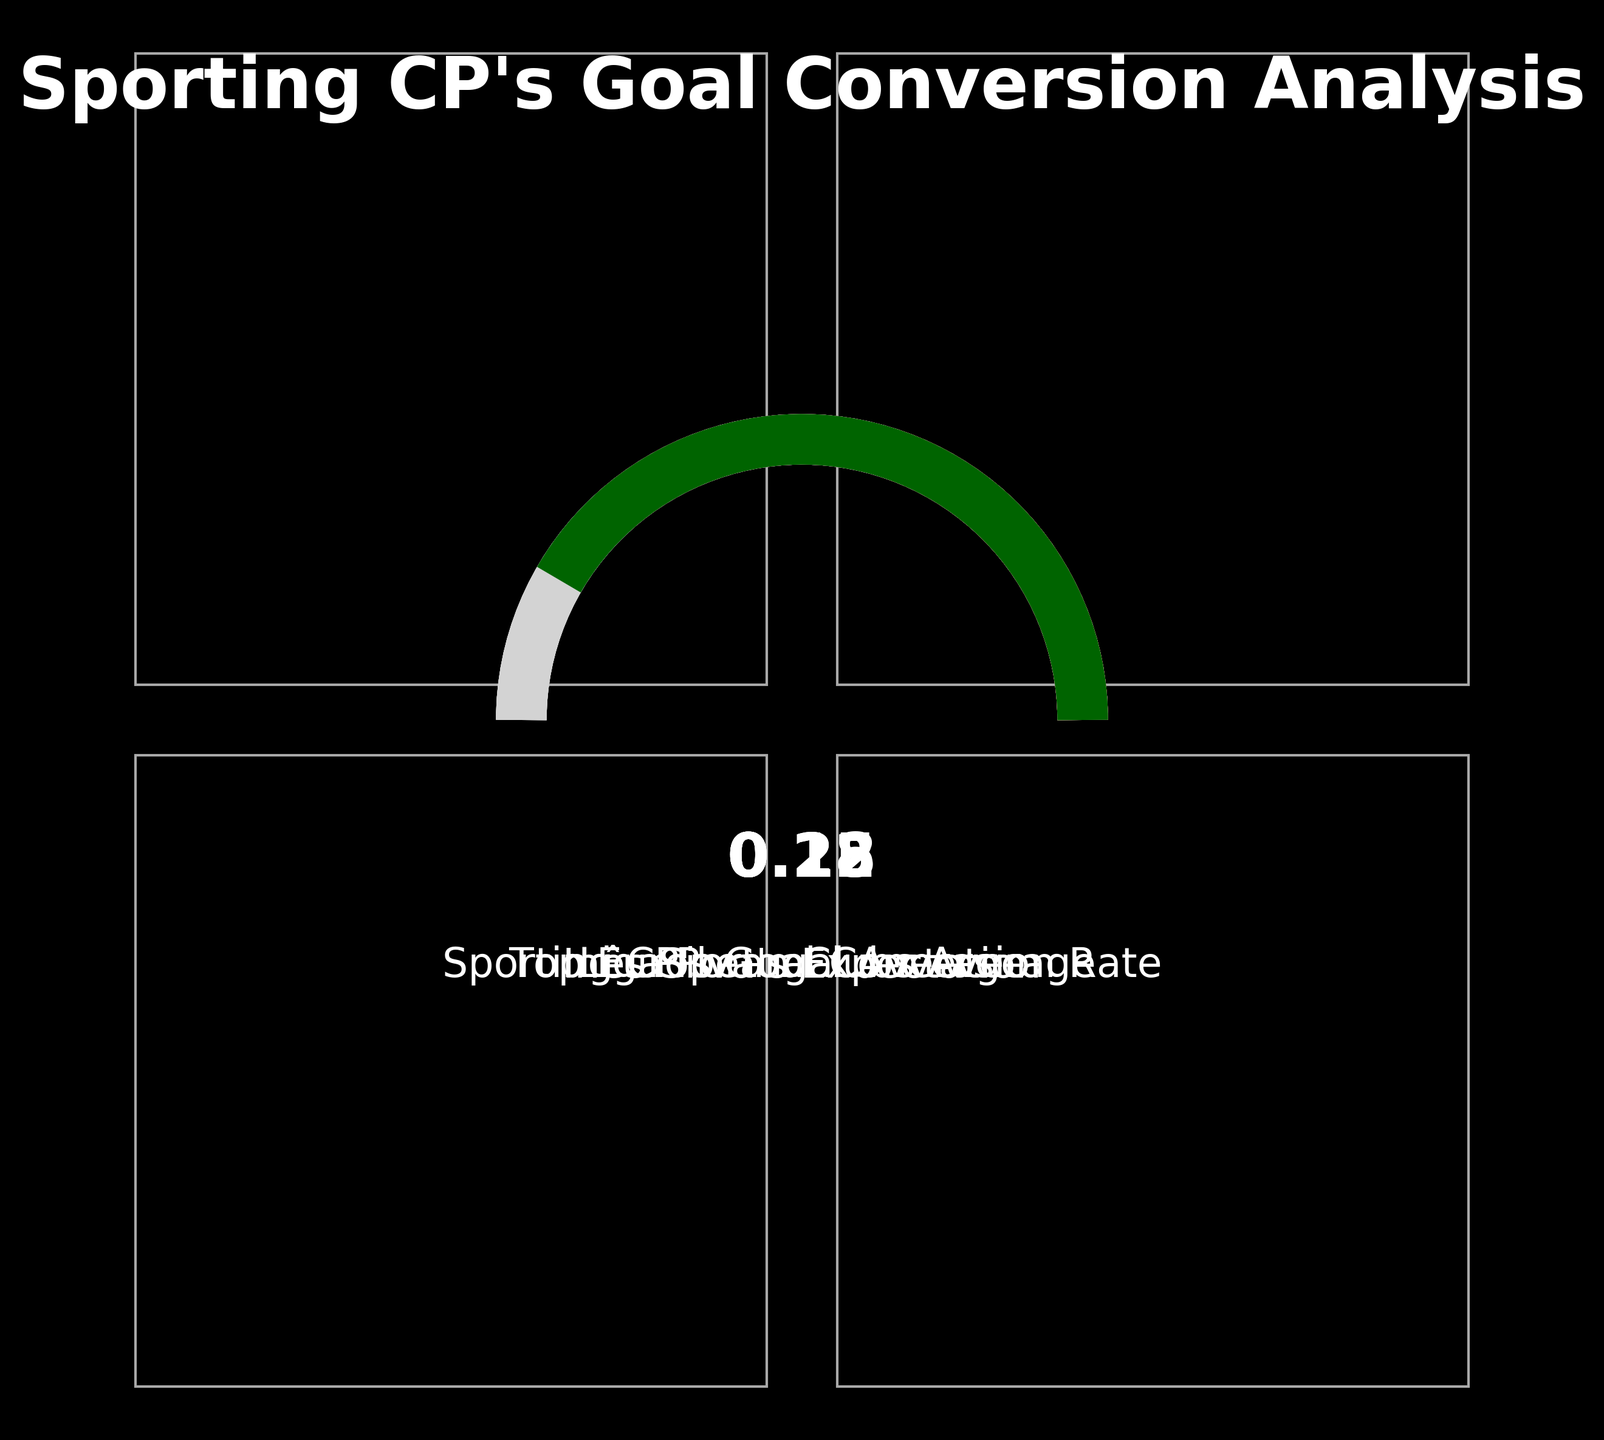What is the label of the gauge with the highest value? The gauge with the highest value is the one with the value 0.25. The label for this gauge is "Top European Clubs Average."
Answer: Top European Clubs Average What color represents Sporting CP's Goal Conversion Rate? The color associated with Sporting CP's Goal Conversion Rate is the first color listed, which is '#1A5F7A'. It is a dark blue color.
Answer: Dark blue How many different labels are shown on the plot? There are four different labels shown on the plot: "Sporting CP's Goal Conversion Rate," "Liga Portugal Average," "Inês Silva's Expectation," and "Top European Clubs Average."
Answer: Four Which gauge represents the expectation of Inês Silva, and what is its value? The gauge representing Inês Silva's Expectation is the one with the label "Inês Silva's Expectation," and its value is 0.22.
Answer: 0.22 How does Sporting CP's Goal Conversion Rate compare to the Liga Portugal Average? Sporting CP's Goal Conversion Rate is 0.18, while the Liga Portugal Average is 0.12. Therefore, Sporting CP's Goal Conversion Rate is higher than the Liga Portugal Average.
Answer: Higher What is the difference between the Top European Clubs Average and Sporting CP's Goal Conversion Rate? The Top European Clubs Average is 0.25, and Sporting CP's Goal Conversion Rate is 0.18. The difference between them is 0.25 - 0.18 = 0.07.
Answer: 0.07 Which gauge is closest in value to Inês Silva's Expectation? Inês Silva's Expectation has a value of 0.22. The closest gauge value to this is the Top European Clubs Average, which is 0.25.
Answer: Top European Clubs Average What is the title of this plot? The title of the plot is "Sporting CP's Goal Conversion Analysis."
Answer: Sporting CP's Goal Conversion Analysis Is Sporting CP's Goal Conversion Rate above or below the Top European Clubs Average? Sporting CP's Goal Conversion Rate is 0.18, which is below the Top European Clubs Average of 0.25.
Answer: Below 